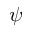Convert formula to latex. <formula><loc_0><loc_0><loc_500><loc_500>\psi</formula> 